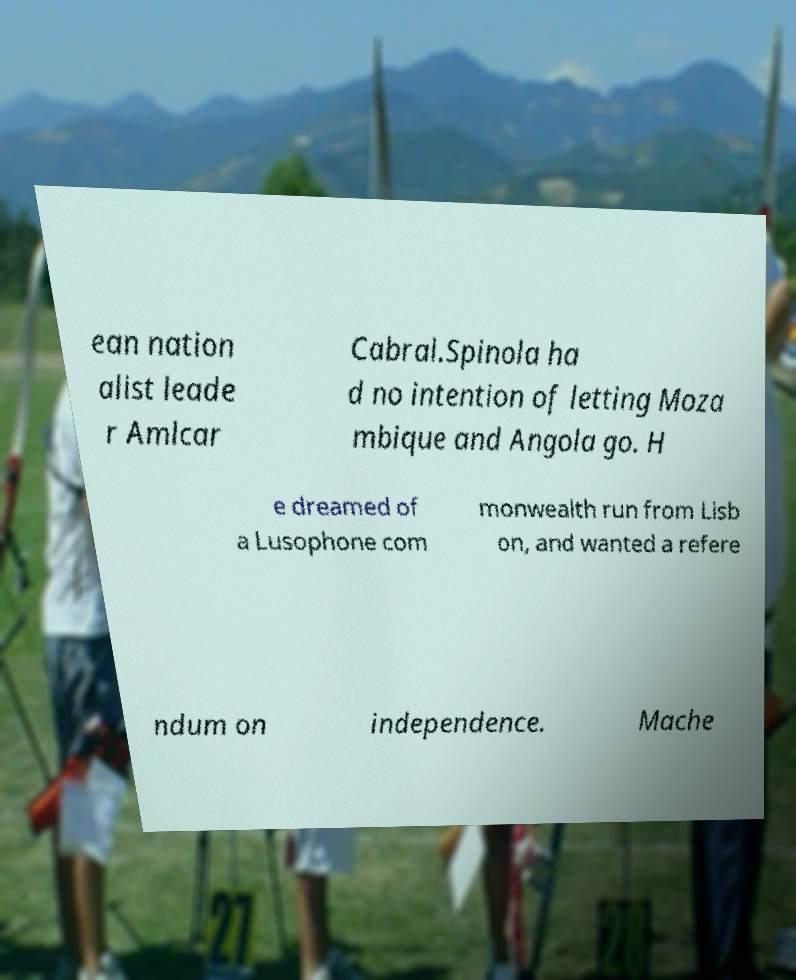What messages or text are displayed in this image? I need them in a readable, typed format. ean nation alist leade r Amlcar Cabral.Spinola ha d no intention of letting Moza mbique and Angola go. H e dreamed of a Lusophone com monwealth run from Lisb on, and wanted a refere ndum on independence. Mache 